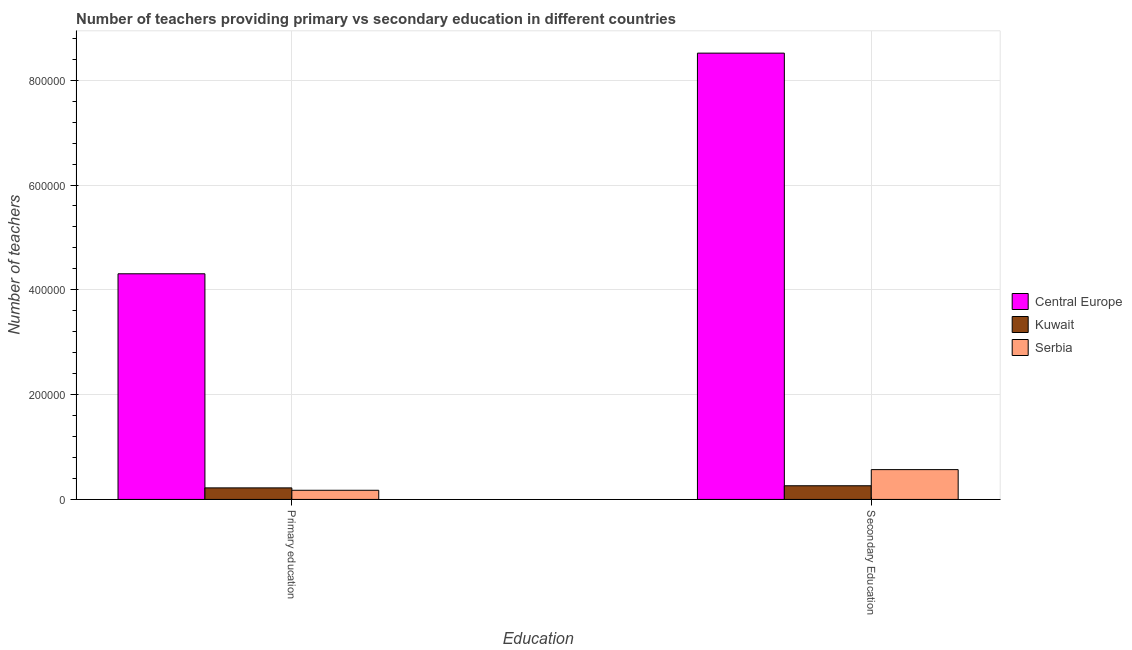How many different coloured bars are there?
Offer a very short reply. 3. How many groups of bars are there?
Keep it short and to the point. 2. Are the number of bars per tick equal to the number of legend labels?
Give a very brief answer. Yes. Are the number of bars on each tick of the X-axis equal?
Provide a succinct answer. Yes. How many bars are there on the 1st tick from the left?
Offer a terse response. 3. How many bars are there on the 1st tick from the right?
Give a very brief answer. 3. What is the label of the 2nd group of bars from the left?
Provide a short and direct response. Secondary Education. What is the number of primary teachers in Serbia?
Your response must be concise. 1.75e+04. Across all countries, what is the maximum number of secondary teachers?
Keep it short and to the point. 8.52e+05. Across all countries, what is the minimum number of primary teachers?
Offer a terse response. 1.75e+04. In which country was the number of secondary teachers maximum?
Provide a short and direct response. Central Europe. In which country was the number of secondary teachers minimum?
Your answer should be very brief. Kuwait. What is the total number of secondary teachers in the graph?
Make the answer very short. 9.35e+05. What is the difference between the number of secondary teachers in Kuwait and that in Serbia?
Provide a succinct answer. -3.08e+04. What is the difference between the number of primary teachers in Serbia and the number of secondary teachers in Central Europe?
Provide a succinct answer. -8.34e+05. What is the average number of primary teachers per country?
Provide a succinct answer. 1.57e+05. What is the difference between the number of secondary teachers and number of primary teachers in Central Europe?
Provide a short and direct response. 4.21e+05. In how many countries, is the number of primary teachers greater than 560000 ?
Your answer should be compact. 0. What is the ratio of the number of primary teachers in Kuwait to that in Central Europe?
Offer a terse response. 0.05. Is the number of secondary teachers in Central Europe less than that in Kuwait?
Provide a succinct answer. No. What does the 3rd bar from the left in Primary education represents?
Provide a short and direct response. Serbia. What does the 1st bar from the right in Primary education represents?
Offer a very short reply. Serbia. Are all the bars in the graph horizontal?
Your answer should be very brief. No. How many countries are there in the graph?
Provide a short and direct response. 3. Are the values on the major ticks of Y-axis written in scientific E-notation?
Keep it short and to the point. No. Does the graph contain any zero values?
Offer a terse response. No. Does the graph contain grids?
Keep it short and to the point. Yes. Where does the legend appear in the graph?
Make the answer very short. Center right. What is the title of the graph?
Give a very brief answer. Number of teachers providing primary vs secondary education in different countries. What is the label or title of the X-axis?
Offer a terse response. Education. What is the label or title of the Y-axis?
Offer a very short reply. Number of teachers. What is the Number of teachers of Central Europe in Primary education?
Your answer should be very brief. 4.31e+05. What is the Number of teachers of Kuwait in Primary education?
Make the answer very short. 2.20e+04. What is the Number of teachers in Serbia in Primary education?
Provide a succinct answer. 1.75e+04. What is the Number of teachers of Central Europe in Secondary Education?
Provide a short and direct response. 8.52e+05. What is the Number of teachers of Kuwait in Secondary Education?
Your answer should be very brief. 2.61e+04. What is the Number of teachers of Serbia in Secondary Education?
Ensure brevity in your answer.  5.69e+04. Across all Education, what is the maximum Number of teachers in Central Europe?
Make the answer very short. 8.52e+05. Across all Education, what is the maximum Number of teachers in Kuwait?
Keep it short and to the point. 2.61e+04. Across all Education, what is the maximum Number of teachers of Serbia?
Ensure brevity in your answer.  5.69e+04. Across all Education, what is the minimum Number of teachers in Central Europe?
Your answer should be compact. 4.31e+05. Across all Education, what is the minimum Number of teachers in Kuwait?
Provide a succinct answer. 2.20e+04. Across all Education, what is the minimum Number of teachers of Serbia?
Your answer should be very brief. 1.75e+04. What is the total Number of teachers in Central Europe in the graph?
Your answer should be compact. 1.28e+06. What is the total Number of teachers in Kuwait in the graph?
Make the answer very short. 4.81e+04. What is the total Number of teachers of Serbia in the graph?
Provide a short and direct response. 7.44e+04. What is the difference between the Number of teachers of Central Europe in Primary education and that in Secondary Education?
Provide a short and direct response. -4.21e+05. What is the difference between the Number of teachers in Kuwait in Primary education and that in Secondary Education?
Your answer should be compact. -4084. What is the difference between the Number of teachers of Serbia in Primary education and that in Secondary Education?
Keep it short and to the point. -3.94e+04. What is the difference between the Number of teachers in Central Europe in Primary education and the Number of teachers in Kuwait in Secondary Education?
Offer a very short reply. 4.05e+05. What is the difference between the Number of teachers in Central Europe in Primary education and the Number of teachers in Serbia in Secondary Education?
Provide a short and direct response. 3.74e+05. What is the difference between the Number of teachers in Kuwait in Primary education and the Number of teachers in Serbia in Secondary Education?
Provide a succinct answer. -3.49e+04. What is the average Number of teachers in Central Europe per Education?
Your answer should be very brief. 6.41e+05. What is the average Number of teachers of Kuwait per Education?
Your answer should be very brief. 2.41e+04. What is the average Number of teachers in Serbia per Education?
Your answer should be very brief. 3.72e+04. What is the difference between the Number of teachers of Central Europe and Number of teachers of Kuwait in Primary education?
Your answer should be very brief. 4.09e+05. What is the difference between the Number of teachers in Central Europe and Number of teachers in Serbia in Primary education?
Provide a succinct answer. 4.13e+05. What is the difference between the Number of teachers in Kuwait and Number of teachers in Serbia in Primary education?
Your answer should be very brief. 4539. What is the difference between the Number of teachers in Central Europe and Number of teachers in Kuwait in Secondary Education?
Your answer should be very brief. 8.26e+05. What is the difference between the Number of teachers of Central Europe and Number of teachers of Serbia in Secondary Education?
Offer a terse response. 7.95e+05. What is the difference between the Number of teachers of Kuwait and Number of teachers of Serbia in Secondary Education?
Provide a short and direct response. -3.08e+04. What is the ratio of the Number of teachers of Central Europe in Primary education to that in Secondary Education?
Your answer should be very brief. 0.51. What is the ratio of the Number of teachers of Kuwait in Primary education to that in Secondary Education?
Offer a terse response. 0.84. What is the ratio of the Number of teachers in Serbia in Primary education to that in Secondary Education?
Make the answer very short. 0.31. What is the difference between the highest and the second highest Number of teachers of Central Europe?
Ensure brevity in your answer.  4.21e+05. What is the difference between the highest and the second highest Number of teachers of Kuwait?
Ensure brevity in your answer.  4084. What is the difference between the highest and the second highest Number of teachers of Serbia?
Make the answer very short. 3.94e+04. What is the difference between the highest and the lowest Number of teachers of Central Europe?
Offer a terse response. 4.21e+05. What is the difference between the highest and the lowest Number of teachers of Kuwait?
Provide a short and direct response. 4084. What is the difference between the highest and the lowest Number of teachers of Serbia?
Offer a terse response. 3.94e+04. 